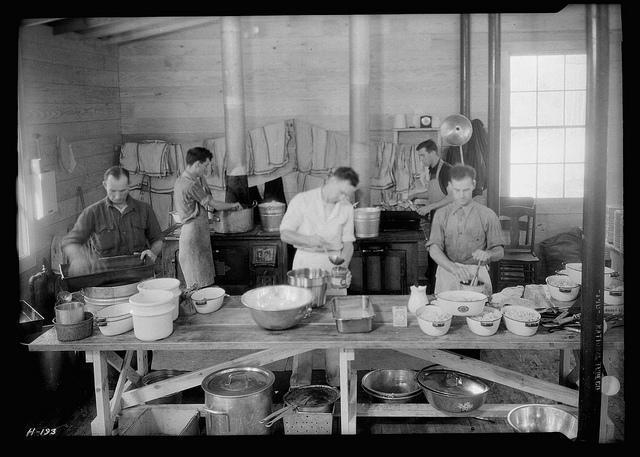How many men are there?
Give a very brief answer. 5. How many people can be seen?
Give a very brief answer. 4. 